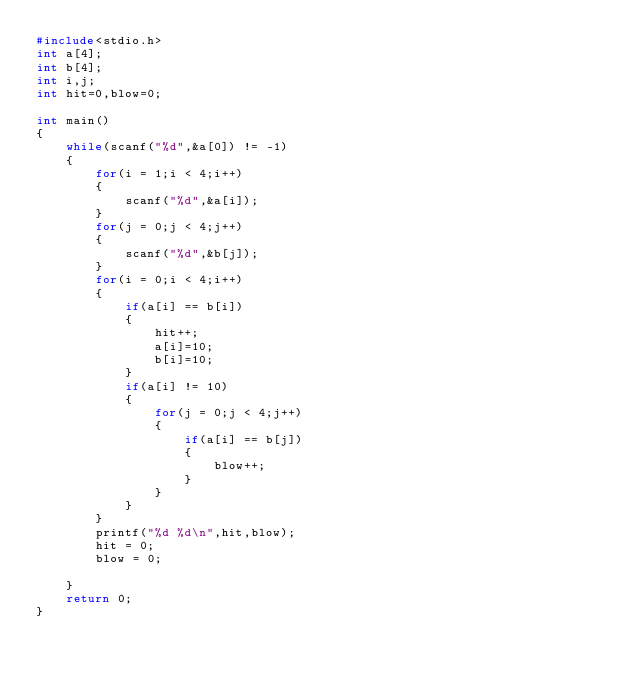Convert code to text. <code><loc_0><loc_0><loc_500><loc_500><_C_>#include<stdio.h>
int a[4];
int b[4];
int i,j;
int hit=0,blow=0;

int main()
{
    while(scanf("%d",&a[0]) != -1)
    {
        for(i = 1;i < 4;i++)
        {
            scanf("%d",&a[i]);
        }
        for(j = 0;j < 4;j++)
        {
            scanf("%d",&b[j]);
        }
        for(i = 0;i < 4;i++)
        {
            if(a[i] == b[i])
            {
                hit++;
                a[i]=10;
                b[i]=10;
            }
            if(a[i] != 10)
            {
                for(j = 0;j < 4;j++)
                {
                    if(a[i] == b[j])
                    {
                        blow++;
                    }
                }
            }
        }
        printf("%d %d\n",hit,blow);
        hit = 0;
        blow = 0;

    }
    return 0;
}</code> 